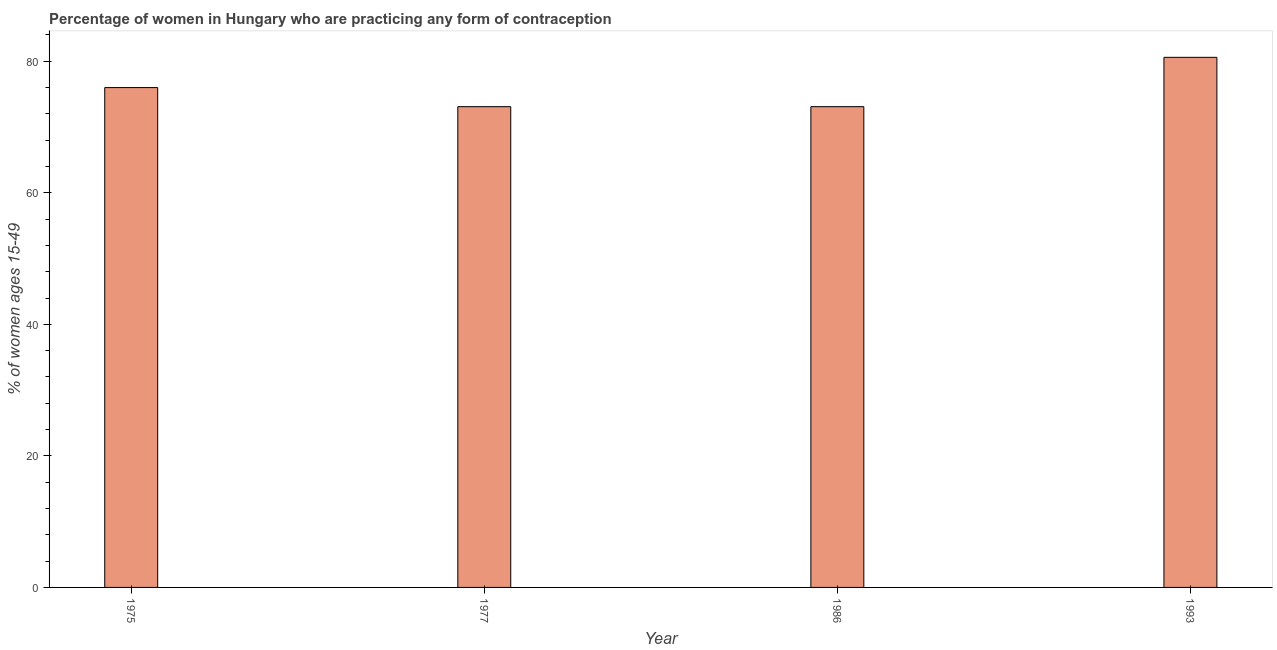Does the graph contain grids?
Keep it short and to the point. No. What is the title of the graph?
Offer a very short reply. Percentage of women in Hungary who are practicing any form of contraception. What is the label or title of the Y-axis?
Provide a succinct answer. % of women ages 15-49. What is the contraceptive prevalence in 1993?
Your answer should be compact. 80.6. Across all years, what is the maximum contraceptive prevalence?
Offer a terse response. 80.6. Across all years, what is the minimum contraceptive prevalence?
Your response must be concise. 73.1. What is the sum of the contraceptive prevalence?
Give a very brief answer. 302.8. What is the average contraceptive prevalence per year?
Provide a succinct answer. 75.7. What is the median contraceptive prevalence?
Offer a terse response. 74.55. In how many years, is the contraceptive prevalence greater than 8 %?
Your answer should be compact. 4. Do a majority of the years between 1977 and 1993 (inclusive) have contraceptive prevalence greater than 56 %?
Give a very brief answer. Yes. What is the ratio of the contraceptive prevalence in 1977 to that in 1986?
Keep it short and to the point. 1. What is the difference between the highest and the lowest contraceptive prevalence?
Your answer should be very brief. 7.5. In how many years, is the contraceptive prevalence greater than the average contraceptive prevalence taken over all years?
Give a very brief answer. 2. What is the % of women ages 15-49 of 1977?
Provide a short and direct response. 73.1. What is the % of women ages 15-49 of 1986?
Make the answer very short. 73.1. What is the % of women ages 15-49 of 1993?
Your answer should be compact. 80.6. What is the difference between the % of women ages 15-49 in 1975 and 1977?
Keep it short and to the point. 2.9. What is the difference between the % of women ages 15-49 in 1975 and 1986?
Provide a succinct answer. 2.9. What is the difference between the % of women ages 15-49 in 1977 and 1986?
Offer a terse response. 0. What is the difference between the % of women ages 15-49 in 1977 and 1993?
Keep it short and to the point. -7.5. What is the difference between the % of women ages 15-49 in 1986 and 1993?
Offer a terse response. -7.5. What is the ratio of the % of women ages 15-49 in 1975 to that in 1986?
Your response must be concise. 1.04. What is the ratio of the % of women ages 15-49 in 1975 to that in 1993?
Give a very brief answer. 0.94. What is the ratio of the % of women ages 15-49 in 1977 to that in 1986?
Offer a very short reply. 1. What is the ratio of the % of women ages 15-49 in 1977 to that in 1993?
Your response must be concise. 0.91. What is the ratio of the % of women ages 15-49 in 1986 to that in 1993?
Your response must be concise. 0.91. 